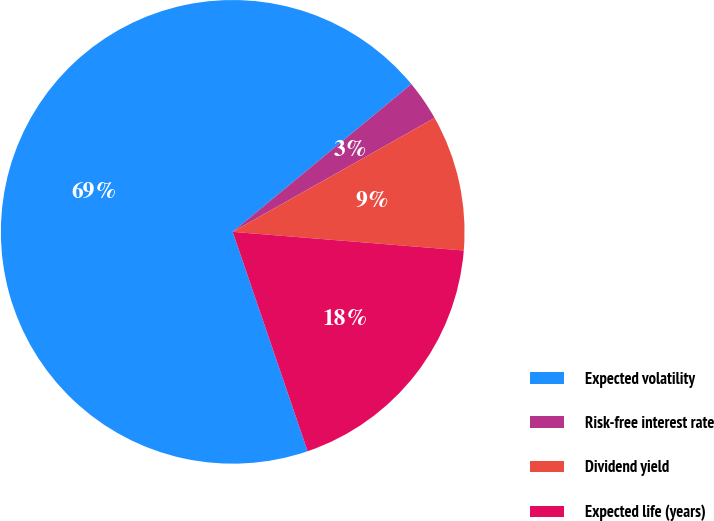<chart> <loc_0><loc_0><loc_500><loc_500><pie_chart><fcel>Expected volatility<fcel>Risk-free interest rate<fcel>Dividend yield<fcel>Expected life (years)<nl><fcel>69.24%<fcel>2.82%<fcel>9.46%<fcel>18.48%<nl></chart> 